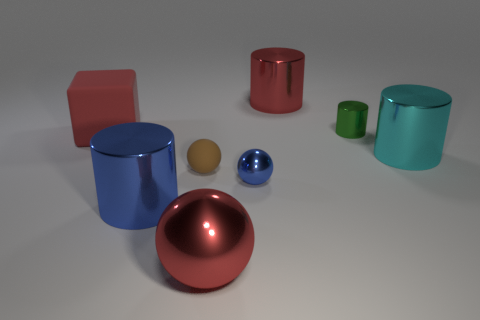There is a cylinder that is the same color as the matte block; what material is it?
Give a very brief answer. Metal. Is there anything else that has the same color as the cube?
Your answer should be compact. Yes. There is a big shiny thing that is the same color as the large metal sphere; what is its shape?
Make the answer very short. Cylinder. Does the large metal object that is behind the tiny green cylinder have the same color as the matte thing that is behind the cyan metal cylinder?
Offer a very short reply. Yes. What number of red objects are on the right side of the small brown matte sphere and behind the matte ball?
Offer a terse response. 1. What is the red cube made of?
Your answer should be very brief. Rubber. What shape is the rubber thing that is the same size as the blue metallic ball?
Offer a terse response. Sphere. Are the big cylinder that is behind the green metallic cylinder and the blue object that is left of the tiny brown matte thing made of the same material?
Your response must be concise. Yes. What number of spheres are there?
Make the answer very short. 3. What number of big blue things are the same shape as the tiny green shiny thing?
Ensure brevity in your answer.  1. 